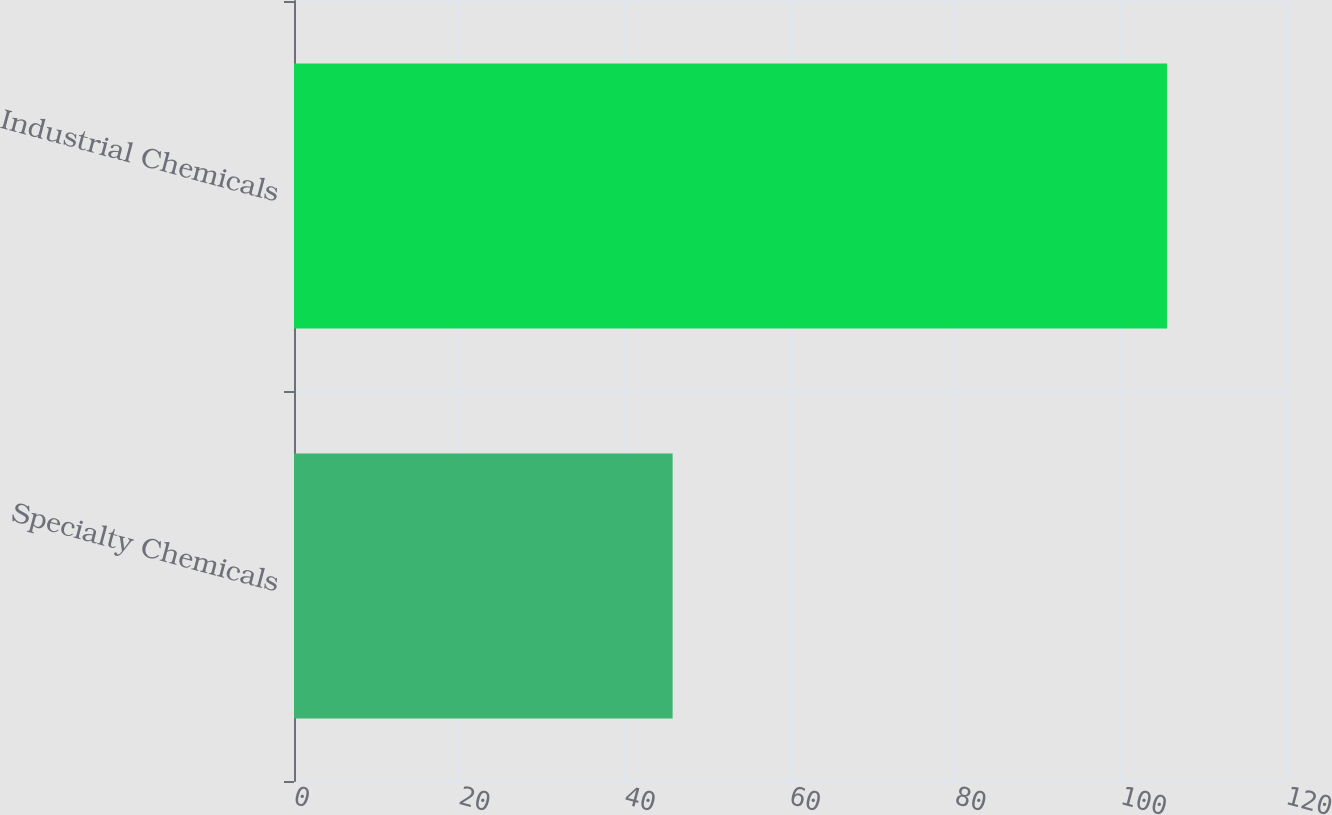Convert chart to OTSL. <chart><loc_0><loc_0><loc_500><loc_500><bar_chart><fcel>Specialty Chemicals<fcel>Industrial Chemicals<nl><fcel>45.8<fcel>105.6<nl></chart> 